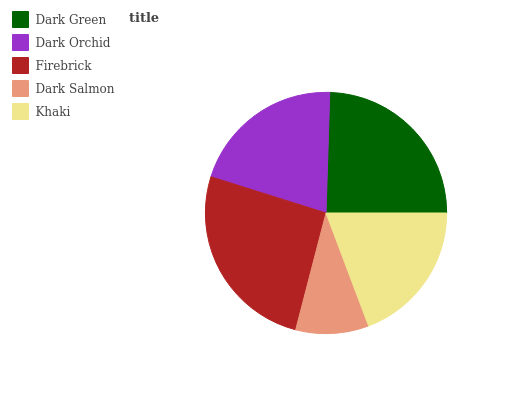Is Dark Salmon the minimum?
Answer yes or no. Yes. Is Firebrick the maximum?
Answer yes or no. Yes. Is Dark Orchid the minimum?
Answer yes or no. No. Is Dark Orchid the maximum?
Answer yes or no. No. Is Dark Green greater than Dark Orchid?
Answer yes or no. Yes. Is Dark Orchid less than Dark Green?
Answer yes or no. Yes. Is Dark Orchid greater than Dark Green?
Answer yes or no. No. Is Dark Green less than Dark Orchid?
Answer yes or no. No. Is Dark Orchid the high median?
Answer yes or no. Yes. Is Dark Orchid the low median?
Answer yes or no. Yes. Is Firebrick the high median?
Answer yes or no. No. Is Dark Green the low median?
Answer yes or no. No. 